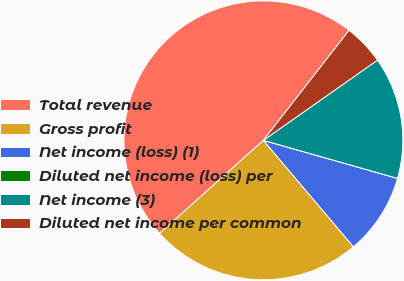Convert chart. <chart><loc_0><loc_0><loc_500><loc_500><pie_chart><fcel>Total revenue<fcel>Gross profit<fcel>Net income (loss) (1)<fcel>Diluted net income (loss) per<fcel>Net income (3)<fcel>Diluted net income per common<nl><fcel>47.16%<fcel>24.54%<fcel>9.43%<fcel>0.0%<fcel>14.15%<fcel>4.72%<nl></chart> 